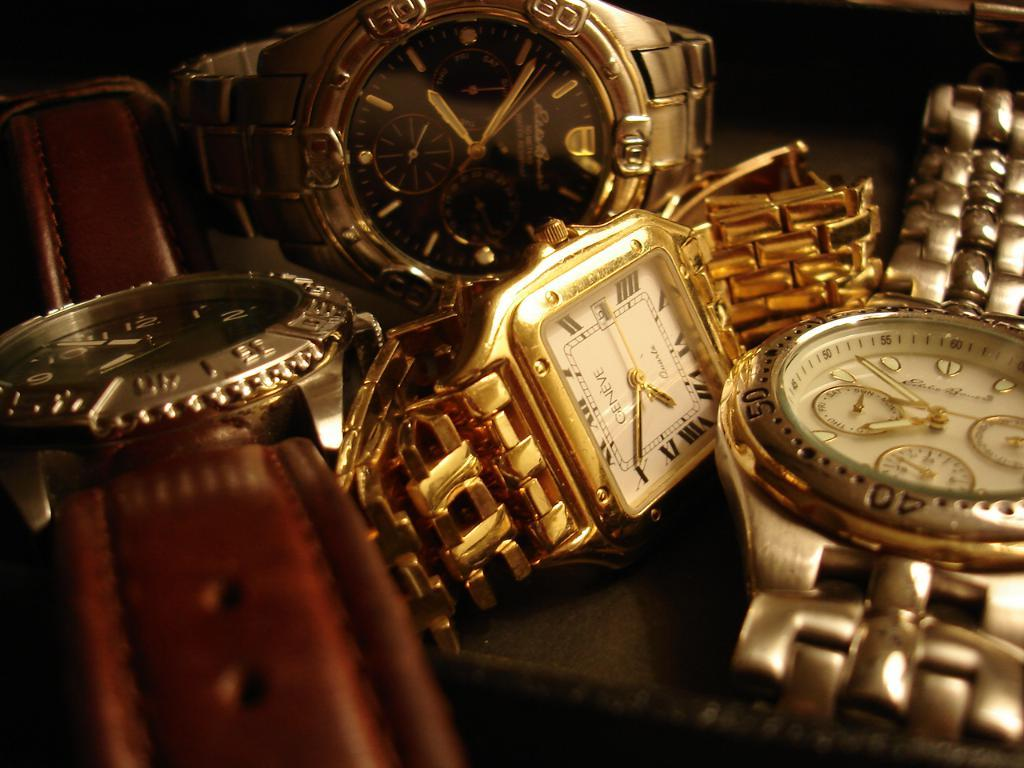Provide a one-sentence caption for the provided image. Four watches placed next to each other with one that is branded Geneve. 